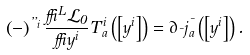<formula> <loc_0><loc_0><loc_500><loc_500>\left ( - \right ) ^ { \varepsilon _ { i } } \frac { \delta ^ { L } \mathcal { L } _ { 0 } } { \delta y ^ { i } } T _ { a } ^ { i } \left ( \left [ y ^ { i } \right ] \right ) = \partial _ { \mu } j _ { a } ^ { \mu } \left ( \left [ y ^ { i } \right ] \right ) .</formula> 